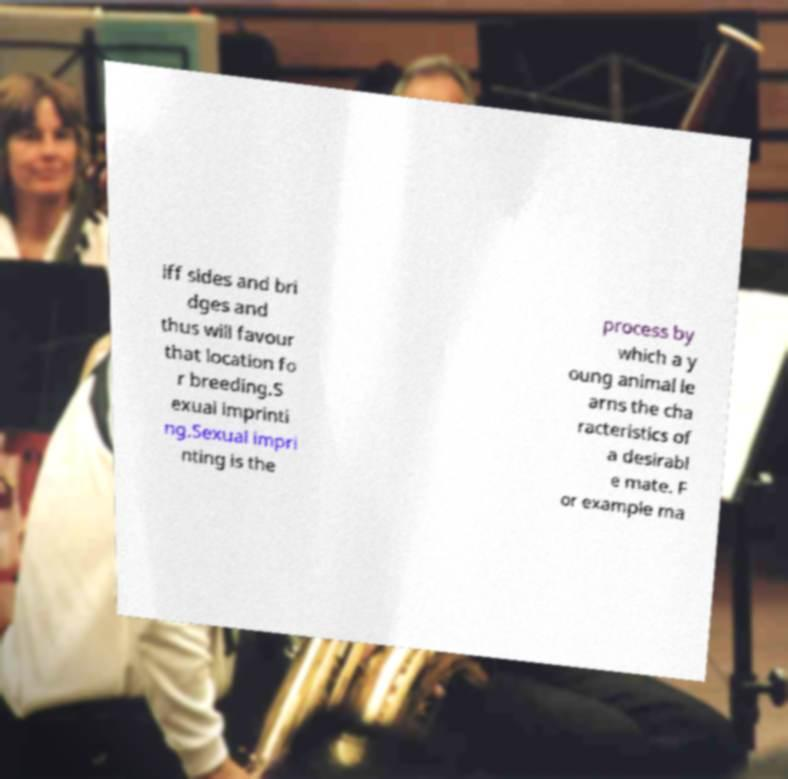Please read and relay the text visible in this image. What does it say? iff sides and bri dges and thus will favour that location fo r breeding.S exual imprinti ng.Sexual impri nting is the process by which a y oung animal le arns the cha racteristics of a desirabl e mate. F or example ma 